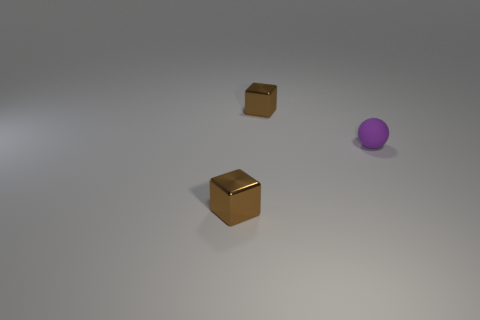There is a small brown thing behind the small metal block that is in front of the purple thing; what is its shape? The small brown object located behind the metal cube, in front of the purple sphere, indeed has a cubic shape with a distinctly visible texture that could suggest a cardboard material. 